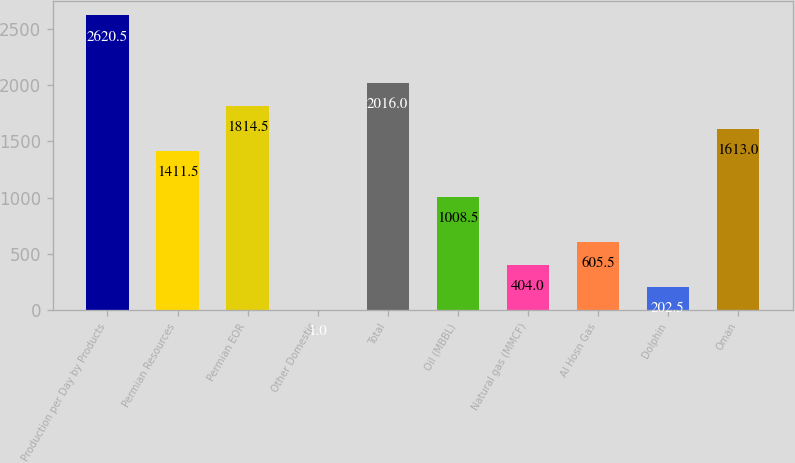<chart> <loc_0><loc_0><loc_500><loc_500><bar_chart><fcel>Production per Day by Products<fcel>Permian Resources<fcel>Permian EOR<fcel>Other Domestic<fcel>Total<fcel>Oil (MBBL)<fcel>Natural gas (MMCF)<fcel>Al Hosn Gas<fcel>Dolphin<fcel>Oman<nl><fcel>2620.5<fcel>1411.5<fcel>1814.5<fcel>1<fcel>2016<fcel>1008.5<fcel>404<fcel>605.5<fcel>202.5<fcel>1613<nl></chart> 